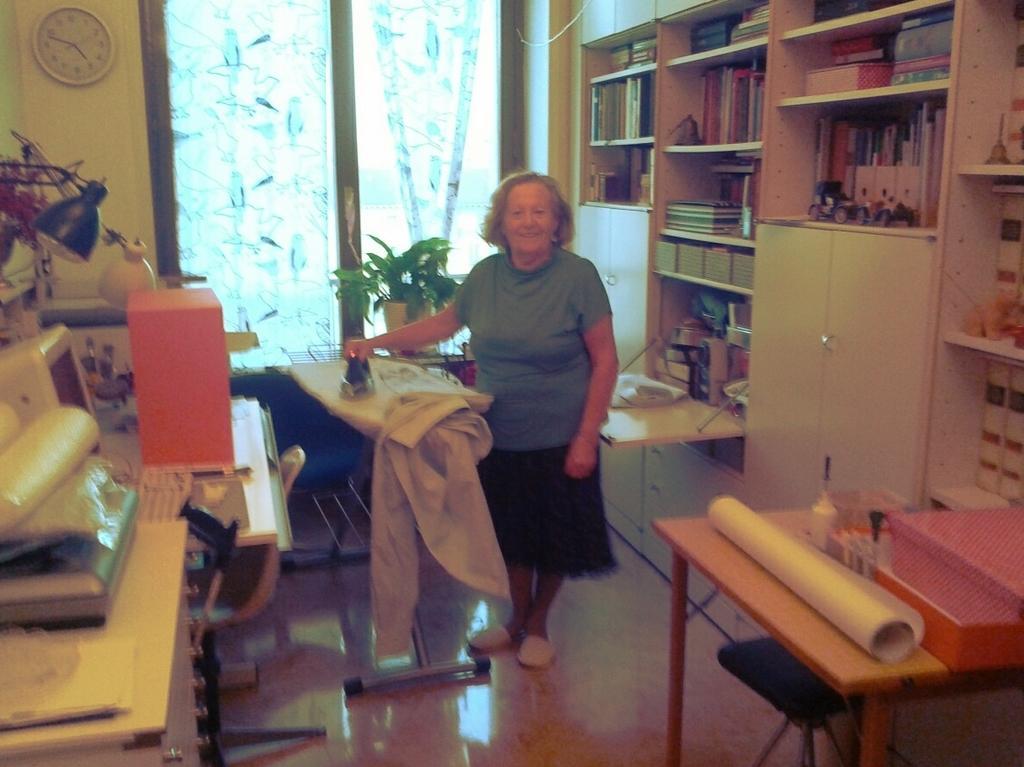In one or two sentences, can you explain what this image depicts? In this image i can see a woman standing and holding a iron box in her hand. I can see a table on which there are few objects on the right side, and in the background i can see a monitor ,a keyboard, a light, a cloth, the wall, window, curtains, bookshelves and a cabinet. 